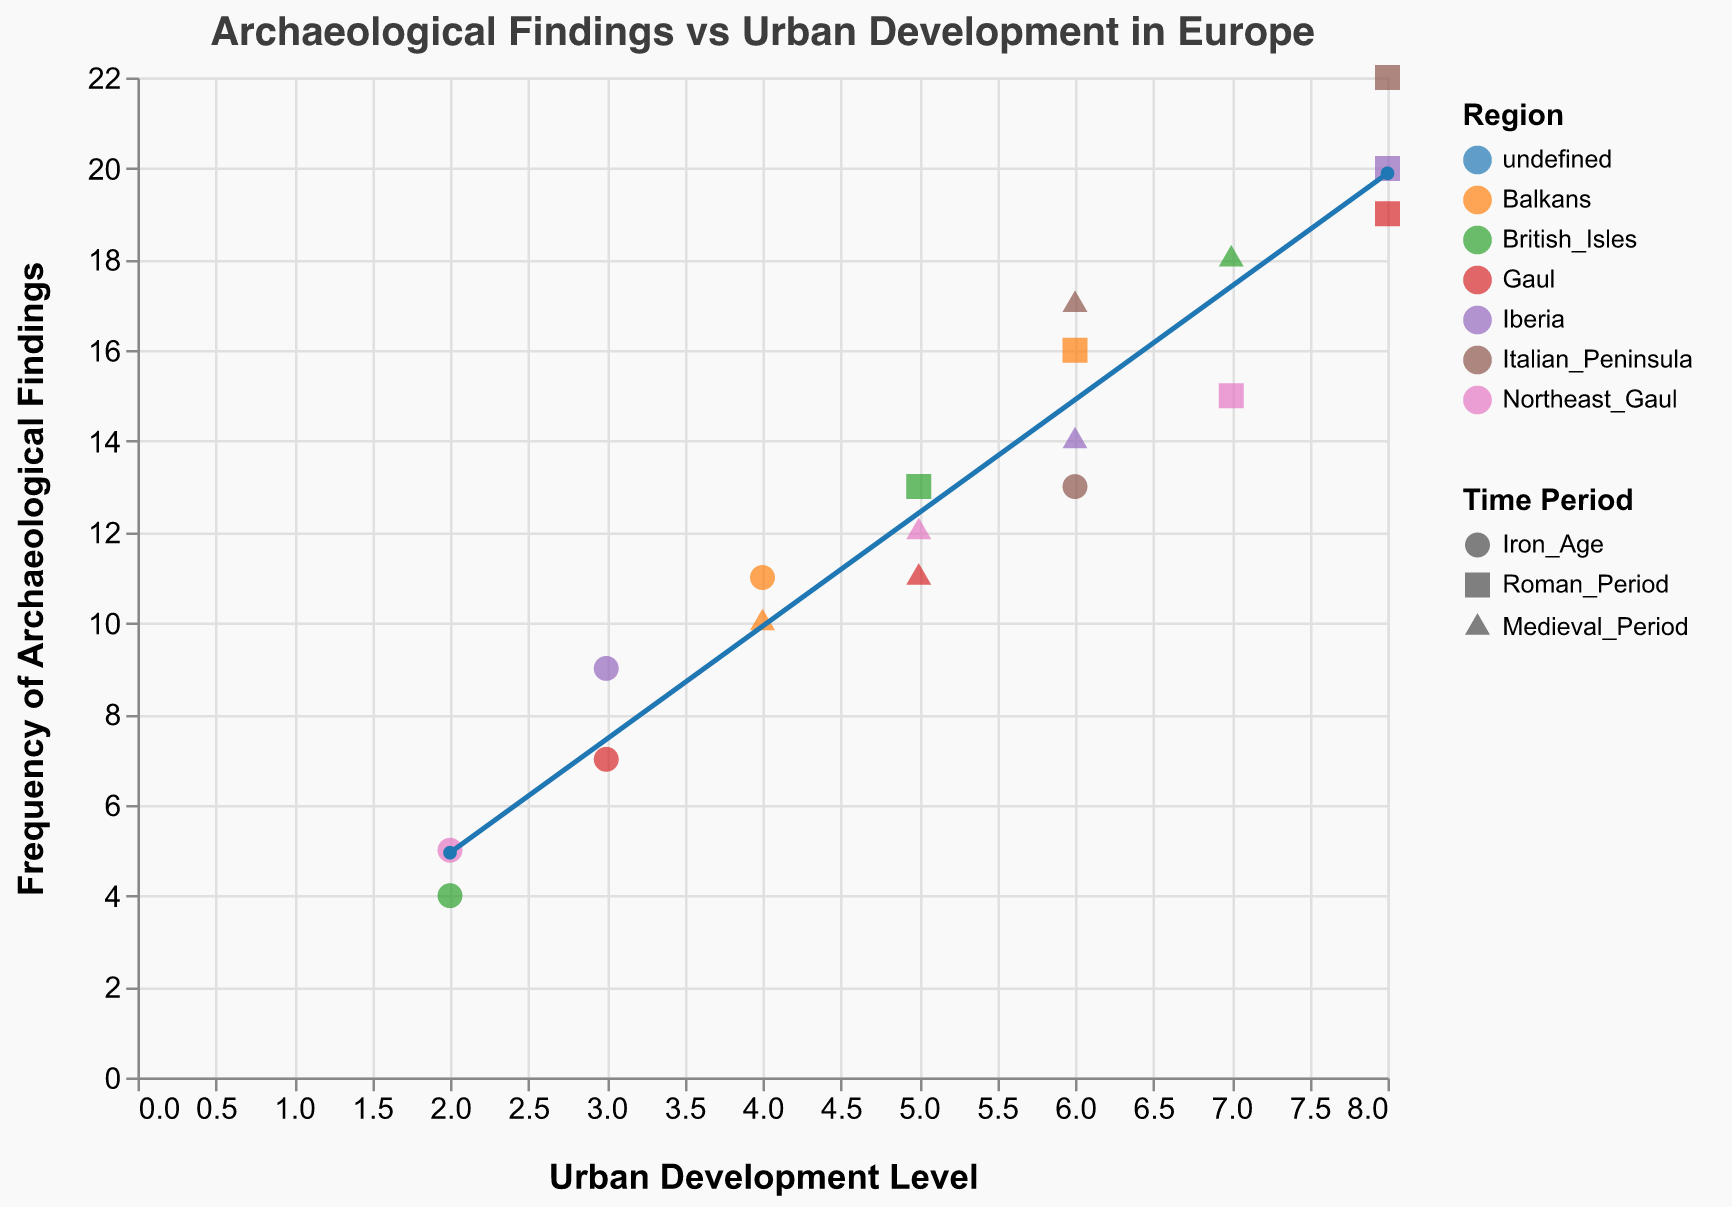What is the title of the figure? The title of the figure is placed at the top and reads "Archaeological Findings vs Urban Development in Europe".
Answer: Archaeological Findings vs Urban Development in Europe What is the x-axis label? The x-axis label is located at the bottom of the figure and it indicates "Urban Development Level".
Answer: Urban Development Level How many data points represent the "Medieval Period"? The points for each time period are indicated by different shapes. There are three triangles for each region for the Medieval Period, making up 5 data points.
Answer: 5 Which region has the highest frequency of archaeological findings during the Roman Period? The frequency values are indicated on the y-axis and the shape "square" denotes the Roman Period. The Italian Peninsula has the highest frequency with a value of 22.
Answer: Italian Peninsula What is the overall trend indicated by the red line? The red line represents a trend line. It shows a positive correlation where the frequency of archaeological findings increases with higher urban development levels.
Answer: Positive correlation Which region has the lowest urban development level in the Medieval Period? The development levels can be read from the x-axis, and triangles indicate the Medieval Period. The British Isles has the lowest development level of 5 in the Medieval Period.
Answer: British Isles What is the difference in the frequency of archaeological findings between the Iron Age and Roman Period in Iberia? For Iberia, the Iron Age frequency is 9 and the Roman Period frequency is 20. The difference is calculated as 20 - 9.
Answer: 11 Which time period had the lowest average urban development level across regions? Average urban development levels are found for each period. The Iron Age has levels of 2, 3, 4, 2, 6, and 3, summing to 20, and averaged by dividing by 6 resulting in ≈ 3.33. The Roman Period has levels 7, 8, 6, 5, 8, and 8, summed to 42 and averaged by dividing by 6 resulting in ≈ 7. The Medieval Period levels are 5, 6, 4, 7, 6, and 5, summed to 33 and averaged by dividing by 6 resulting in ≈ 5.5. The Iron Age has the lowest average of ≈ 3.33.
Answer: Iron Age Do the Balkans have a higher frequency of archaeological findings in the Iron Age or Medieval Period? In the Balkans, the frequency value for the Iron Age is 11 and for the Medieval Period is 10.
Answer: Iron Age Is there any data point in the figure where urban development level is 8 and the frequency of archaeological findings is less than 20? Observing data points at urban development level 8, those with frequencies below 20 are in Gaul (19) and Italian Peninsula (22), none of which are below 20.
Answer: No 